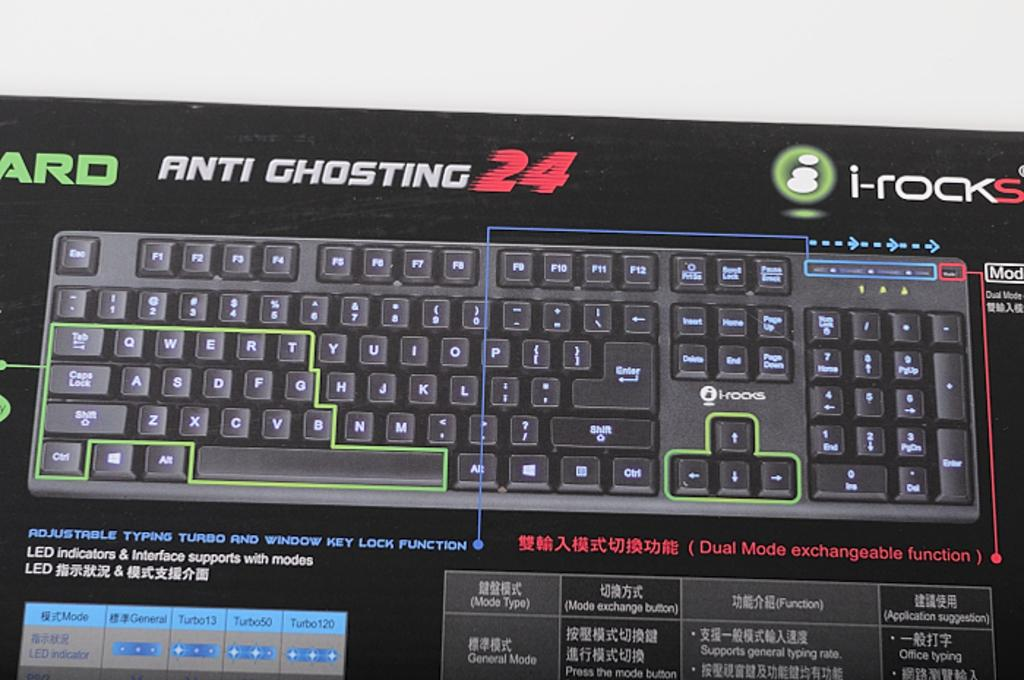<image>
Write a terse but informative summary of the picture. The Anit Ghosting 24 keyboard by i-rocks includes features like adjustable typing turbo and window key lock. 